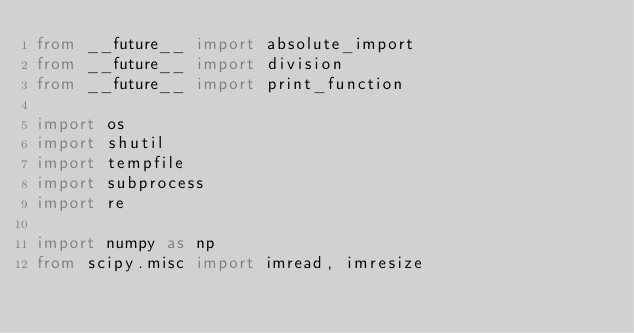Convert code to text. <code><loc_0><loc_0><loc_500><loc_500><_Python_>from __future__ import absolute_import
from __future__ import division
from __future__ import print_function

import os
import shutil
import tempfile
import subprocess
import re

import numpy as np
from scipy.misc import imread, imresize</code> 